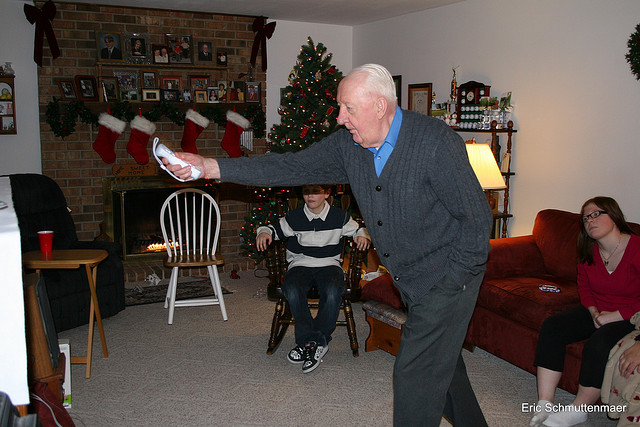<image>Is a teen playing Wii? No, a teen is not playing Wii. Is a teen playing Wii? I don't know if a teen is playing Wii. It seems like the answer is no. 